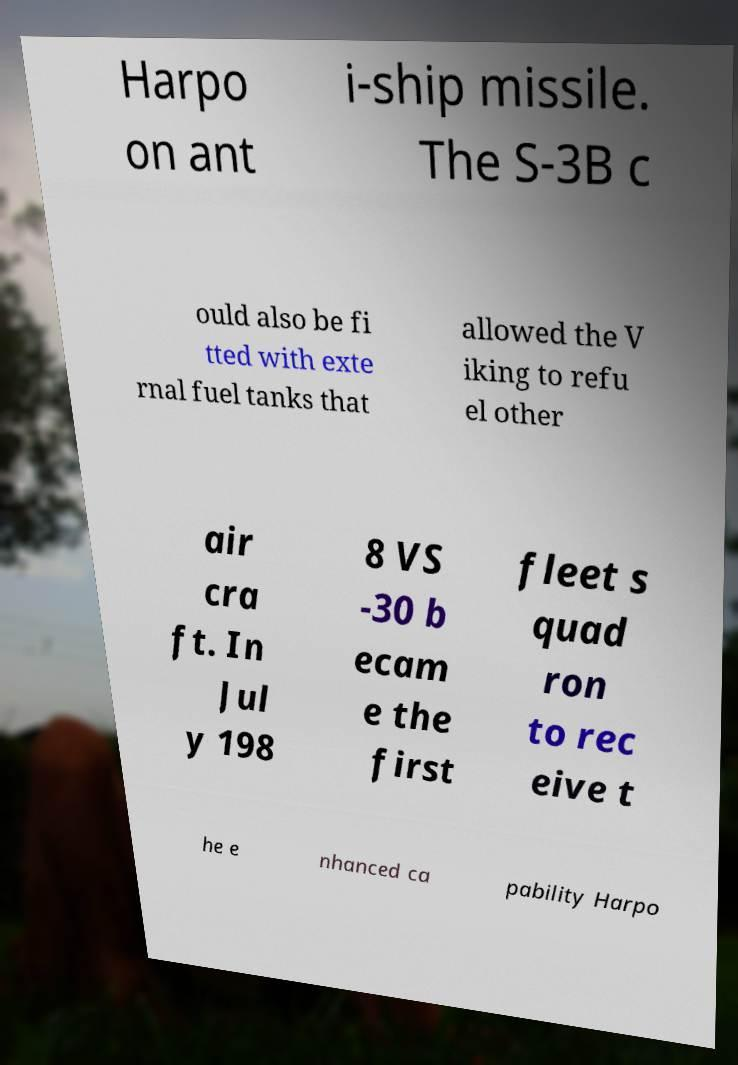Please identify and transcribe the text found in this image. Harpo on ant i-ship missile. The S-3B c ould also be fi tted with exte rnal fuel tanks that allowed the V iking to refu el other air cra ft. In Jul y 198 8 VS -30 b ecam e the first fleet s quad ron to rec eive t he e nhanced ca pability Harpo 